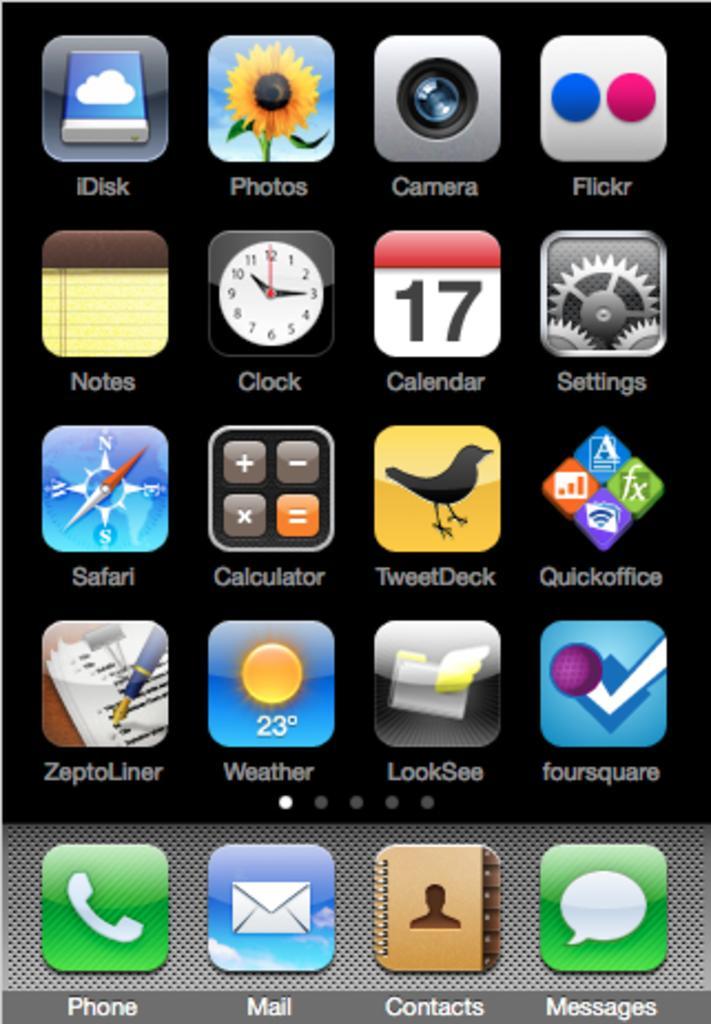In one or two sentences, can you explain what this image depicts? This is a mobile screen and in this screen we can see app symbols. 